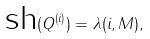<formula> <loc_0><loc_0><loc_500><loc_500>\text {sh} ( Q ^ { ( i ) } ) = \lambda ( i , M ) ,</formula> 